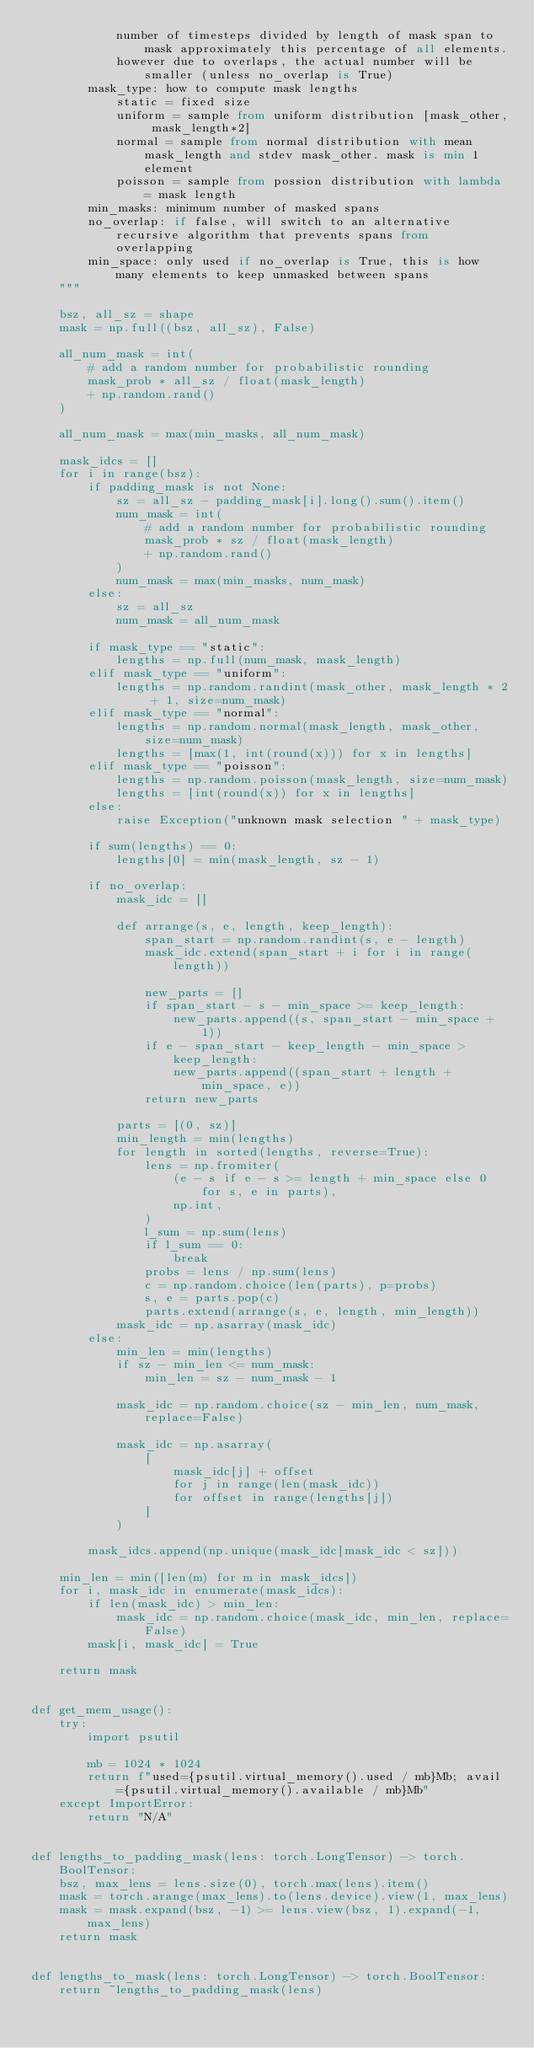Convert code to text. <code><loc_0><loc_0><loc_500><loc_500><_Python_>            number of timesteps divided by length of mask span to mask approximately this percentage of all elements.
            however due to overlaps, the actual number will be smaller (unless no_overlap is True)
        mask_type: how to compute mask lengths
            static = fixed size
            uniform = sample from uniform distribution [mask_other, mask_length*2]
            normal = sample from normal distribution with mean mask_length and stdev mask_other. mask is min 1 element
            poisson = sample from possion distribution with lambda = mask length
        min_masks: minimum number of masked spans
        no_overlap: if false, will switch to an alternative recursive algorithm that prevents spans from overlapping
        min_space: only used if no_overlap is True, this is how many elements to keep unmasked between spans
    """

    bsz, all_sz = shape
    mask = np.full((bsz, all_sz), False)

    all_num_mask = int(
        # add a random number for probabilistic rounding
        mask_prob * all_sz / float(mask_length)
        + np.random.rand()
    )

    all_num_mask = max(min_masks, all_num_mask)

    mask_idcs = []
    for i in range(bsz):
        if padding_mask is not None:
            sz = all_sz - padding_mask[i].long().sum().item()
            num_mask = int(
                # add a random number for probabilistic rounding
                mask_prob * sz / float(mask_length)
                + np.random.rand()
            )
            num_mask = max(min_masks, num_mask)
        else:
            sz = all_sz
            num_mask = all_num_mask

        if mask_type == "static":
            lengths = np.full(num_mask, mask_length)
        elif mask_type == "uniform":
            lengths = np.random.randint(mask_other, mask_length * 2 + 1, size=num_mask)
        elif mask_type == "normal":
            lengths = np.random.normal(mask_length, mask_other, size=num_mask)
            lengths = [max(1, int(round(x))) for x in lengths]
        elif mask_type == "poisson":
            lengths = np.random.poisson(mask_length, size=num_mask)
            lengths = [int(round(x)) for x in lengths]
        else:
            raise Exception("unknown mask selection " + mask_type)

        if sum(lengths) == 0:
            lengths[0] = min(mask_length, sz - 1)

        if no_overlap:
            mask_idc = []

            def arrange(s, e, length, keep_length):
                span_start = np.random.randint(s, e - length)
                mask_idc.extend(span_start + i for i in range(length))

                new_parts = []
                if span_start - s - min_space >= keep_length:
                    new_parts.append((s, span_start - min_space + 1))
                if e - span_start - keep_length - min_space > keep_length:
                    new_parts.append((span_start + length + min_space, e))
                return new_parts

            parts = [(0, sz)]
            min_length = min(lengths)
            for length in sorted(lengths, reverse=True):
                lens = np.fromiter(
                    (e - s if e - s >= length + min_space else 0 for s, e in parts),
                    np.int,
                )
                l_sum = np.sum(lens)
                if l_sum == 0:
                    break
                probs = lens / np.sum(lens)
                c = np.random.choice(len(parts), p=probs)
                s, e = parts.pop(c)
                parts.extend(arrange(s, e, length, min_length))
            mask_idc = np.asarray(mask_idc)
        else:
            min_len = min(lengths)
            if sz - min_len <= num_mask:
                min_len = sz - num_mask - 1

            mask_idc = np.random.choice(sz - min_len, num_mask, replace=False)

            mask_idc = np.asarray(
                [
                    mask_idc[j] + offset
                    for j in range(len(mask_idc))
                    for offset in range(lengths[j])
                ]
            )

        mask_idcs.append(np.unique(mask_idc[mask_idc < sz]))

    min_len = min([len(m) for m in mask_idcs])
    for i, mask_idc in enumerate(mask_idcs):
        if len(mask_idc) > min_len:
            mask_idc = np.random.choice(mask_idc, min_len, replace=False)
        mask[i, mask_idc] = True

    return mask


def get_mem_usage():
    try:
        import psutil

        mb = 1024 * 1024
        return f"used={psutil.virtual_memory().used / mb}Mb; avail={psutil.virtual_memory().available / mb}Mb"
    except ImportError:
        return "N/A"


def lengths_to_padding_mask(lens: torch.LongTensor) -> torch.BoolTensor:
    bsz, max_lens = lens.size(0), torch.max(lens).item()
    mask = torch.arange(max_lens).to(lens.device).view(1, max_lens)
    mask = mask.expand(bsz, -1) >= lens.view(bsz, 1).expand(-1, max_lens)
    return mask


def lengths_to_mask(lens: torch.LongTensor) -> torch.BoolTensor:
    return ~lengths_to_padding_mask(lens)
</code> 